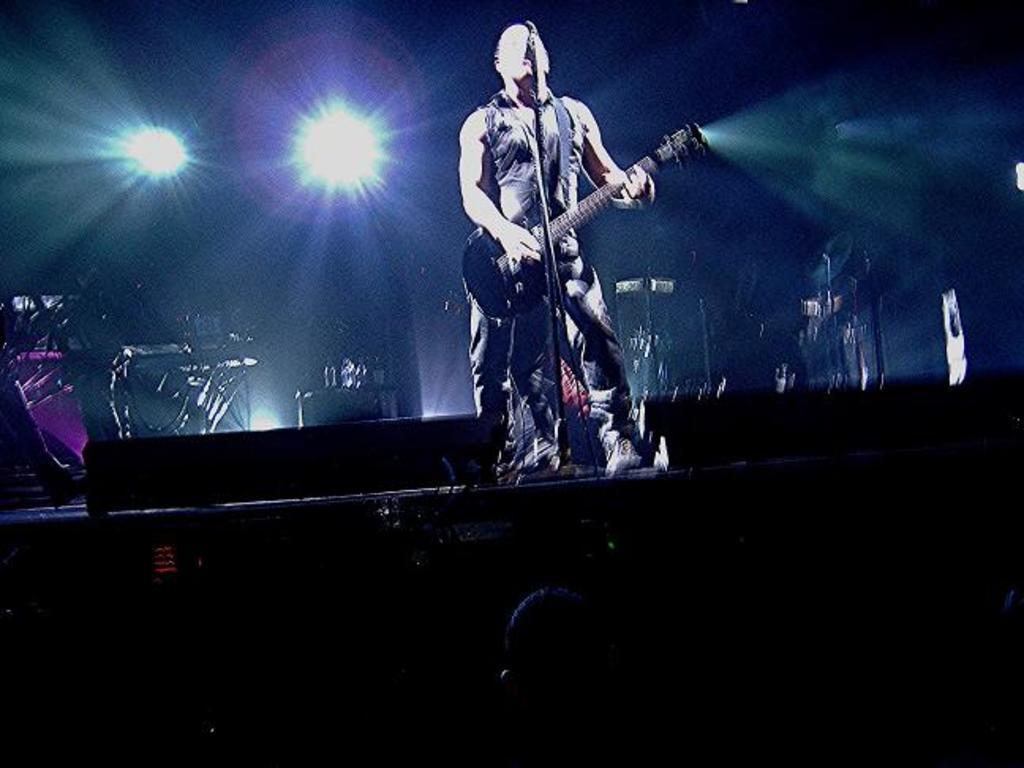Please provide a concise description of this image. In this image we can see a man is standing on the stage and playing guitar. In front of him mic is there. Background of the image musical instruments and light is present. 